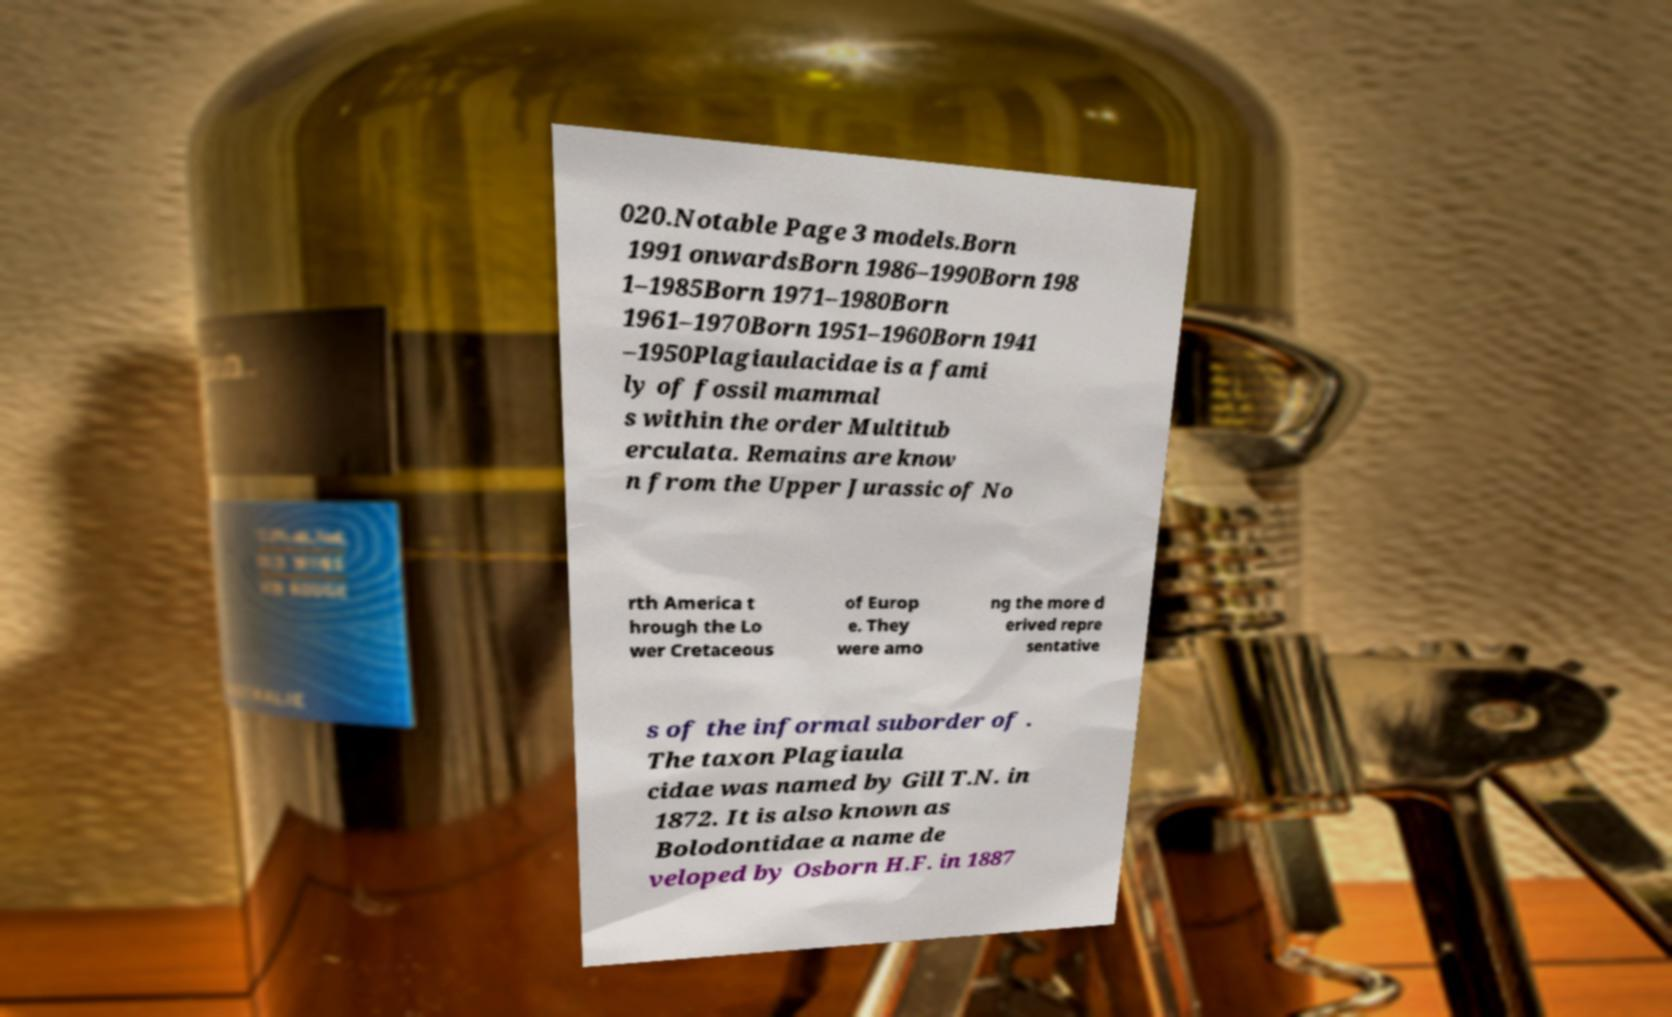Could you extract and type out the text from this image? 020.Notable Page 3 models.Born 1991 onwardsBorn 1986–1990Born 198 1–1985Born 1971–1980Born 1961–1970Born 1951–1960Born 1941 –1950Plagiaulacidae is a fami ly of fossil mammal s within the order Multitub erculata. Remains are know n from the Upper Jurassic of No rth America t hrough the Lo wer Cretaceous of Europ e. They were amo ng the more d erived repre sentative s of the informal suborder of . The taxon Plagiaula cidae was named by Gill T.N. in 1872. It is also known as Bolodontidae a name de veloped by Osborn H.F. in 1887 